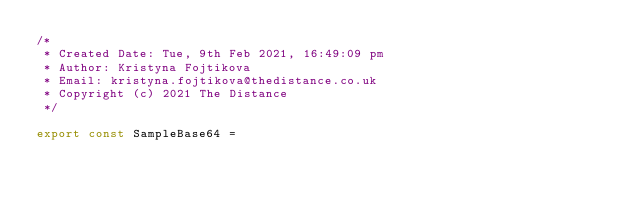Convert code to text. <code><loc_0><loc_0><loc_500><loc_500><_JavaScript_>/*
 * Created Date: Tue, 9th Feb 2021, 16:49:09 pm
 * Author: Kristyna Fojtikova
 * Email: kristyna.fojtikova@thedistance.co.uk
 * Copyright (c) 2021 The Distance
 */

export const SampleBase64 =</code> 